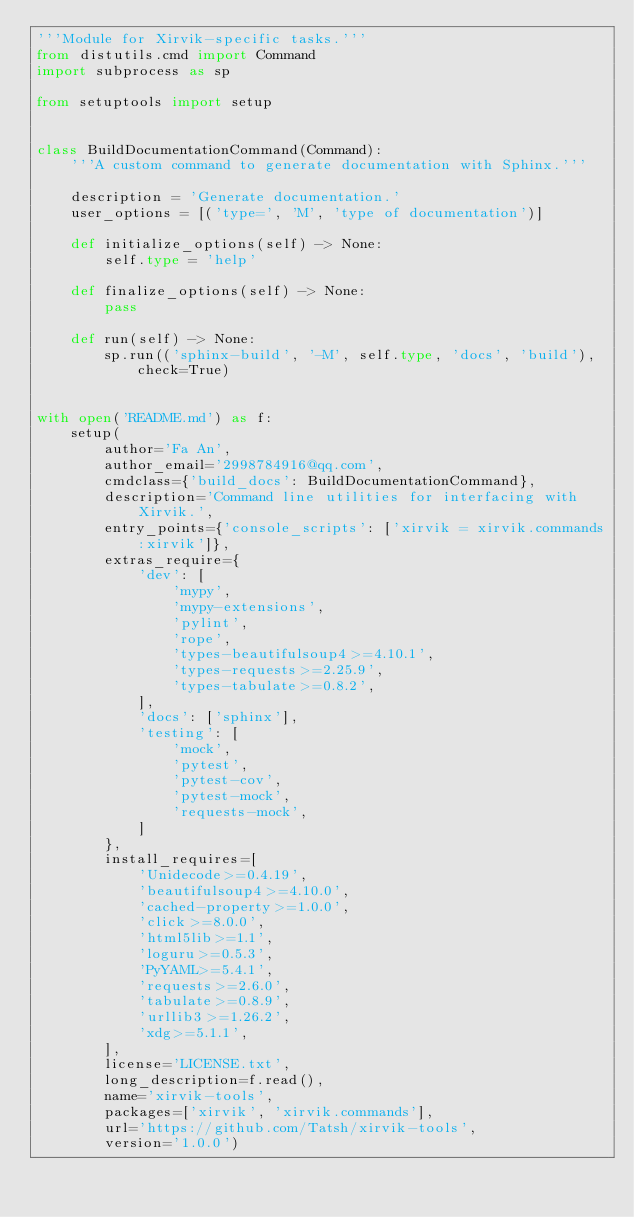Convert code to text. <code><loc_0><loc_0><loc_500><loc_500><_Python_>'''Module for Xirvik-specific tasks.'''
from distutils.cmd import Command
import subprocess as sp

from setuptools import setup


class BuildDocumentationCommand(Command):
    '''A custom command to generate documentation with Sphinx.'''

    description = 'Generate documentation.'
    user_options = [('type=', 'M', 'type of documentation')]

    def initialize_options(self) -> None:
        self.type = 'help'

    def finalize_options(self) -> None:
        pass

    def run(self) -> None:
        sp.run(('sphinx-build', '-M', self.type, 'docs', 'build'), check=True)


with open('README.md') as f:
    setup(
        author='Fa An',
        author_email='2998784916@qq.com',
        cmdclass={'build_docs': BuildDocumentationCommand},
        description='Command line utilities for interfacing with Xirvik.',
        entry_points={'console_scripts': ['xirvik = xirvik.commands:xirvik']},
        extras_require={
            'dev': [
                'mypy',
                'mypy-extensions',
                'pylint',
                'rope',
                'types-beautifulsoup4>=4.10.1',
                'types-requests>=2.25.9',
                'types-tabulate>=0.8.2',
            ],
            'docs': ['sphinx'],
            'testing': [
                'mock',
                'pytest',
                'pytest-cov',
                'pytest-mock',
                'requests-mock',
            ]
        },
        install_requires=[
            'Unidecode>=0.4.19',
            'beautifulsoup4>=4.10.0',
            'cached-property>=1.0.0',
            'click>=8.0.0',
            'html5lib>=1.1',
            'loguru>=0.5.3',
            'PyYAML>=5.4.1',
            'requests>=2.6.0',
            'tabulate>=0.8.9',
            'urllib3>=1.26.2',
            'xdg>=5.1.1',
        ],
        license='LICENSE.txt',
        long_description=f.read(),
        name='xirvik-tools',
        packages=['xirvik', 'xirvik.commands'],
        url='https://github.com/Tatsh/xirvik-tools',
        version='1.0.0')
</code> 